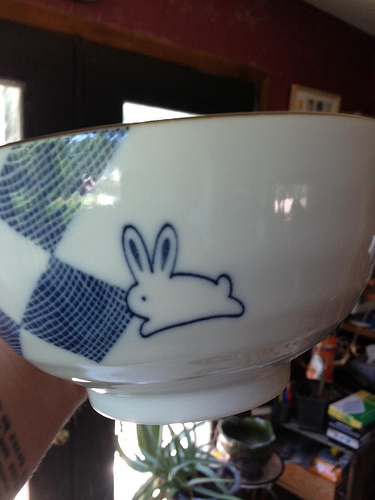<image>
Is the bunny on the bowl? Yes. Looking at the image, I can see the bunny is positioned on top of the bowl, with the bowl providing support. 